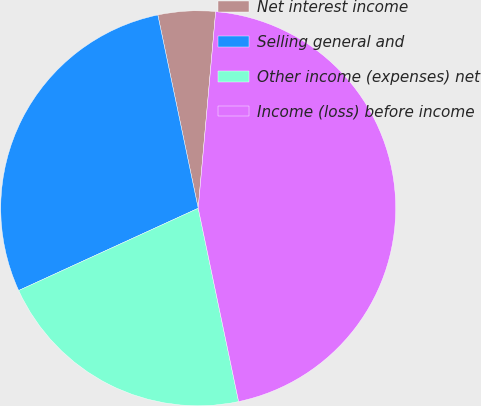Convert chart. <chart><loc_0><loc_0><loc_500><loc_500><pie_chart><fcel>Net interest income<fcel>Selling general and<fcel>Other income (expenses) net<fcel>Income (loss) before income<nl><fcel>4.69%<fcel>28.56%<fcel>21.44%<fcel>45.31%<nl></chart> 